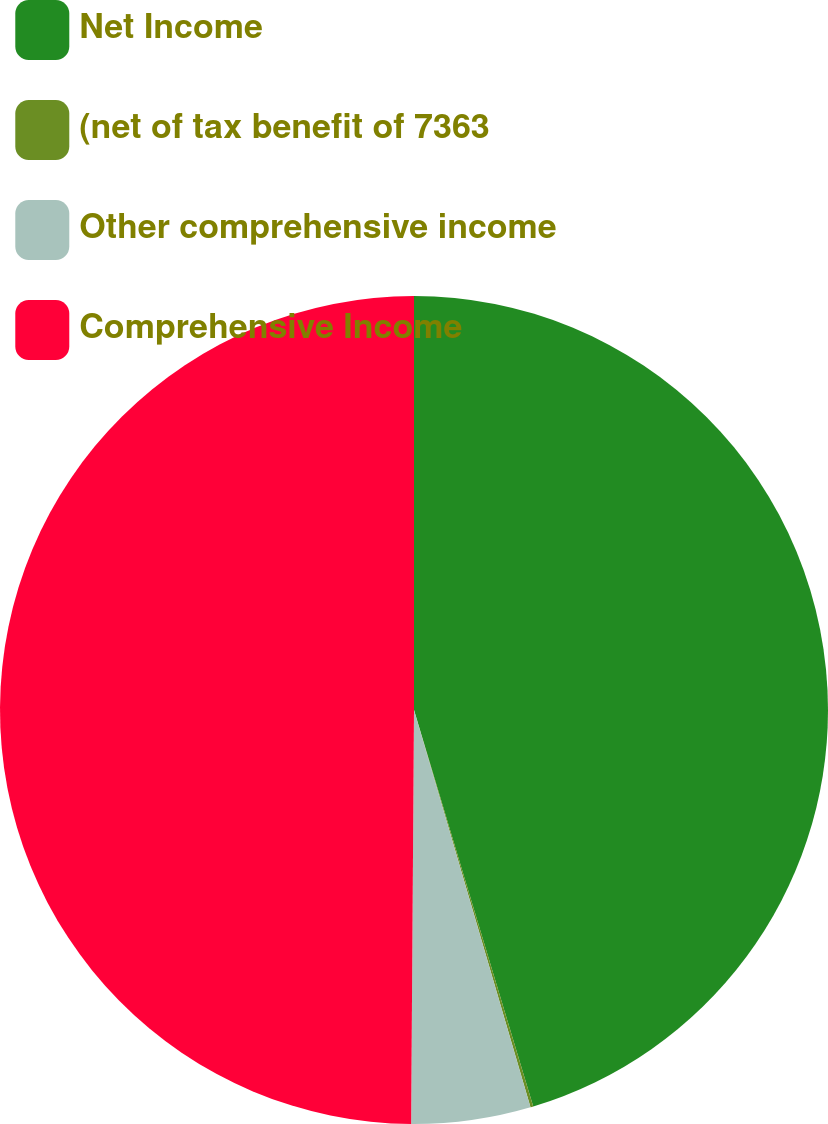<chart> <loc_0><loc_0><loc_500><loc_500><pie_chart><fcel>Net Income<fcel>(net of tax benefit of 7363<fcel>Other comprehensive income<fcel>Comprehensive Income<nl><fcel>45.35%<fcel>0.11%<fcel>4.65%<fcel>49.89%<nl></chart> 